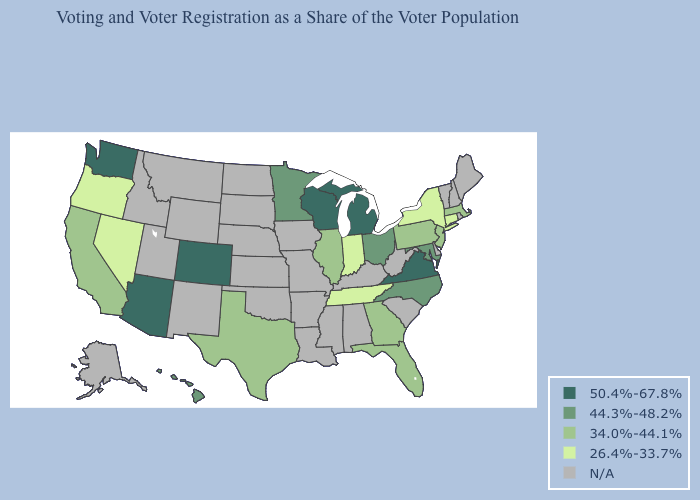Which states have the lowest value in the USA?
Short answer required. Connecticut, Indiana, Nevada, New York, Oregon, Tennessee. What is the highest value in states that border South Dakota?
Give a very brief answer. 44.3%-48.2%. What is the value of Maine?
Be succinct. N/A. What is the value of Colorado?
Give a very brief answer. 50.4%-67.8%. What is the value of Utah?
Keep it brief. N/A. What is the value of Iowa?
Concise answer only. N/A. What is the highest value in the West ?
Write a very short answer. 50.4%-67.8%. Name the states that have a value in the range 44.3%-48.2%?
Be succinct. Hawaii, Maryland, Minnesota, North Carolina, Ohio. What is the value of Rhode Island?
Keep it brief. N/A. Which states have the lowest value in the West?
Concise answer only. Nevada, Oregon. Among the states that border Michigan , which have the highest value?
Keep it brief. Wisconsin. Which states have the lowest value in the South?
Be succinct. Tennessee. Among the states that border North Carolina , does Georgia have the lowest value?
Write a very short answer. No. 